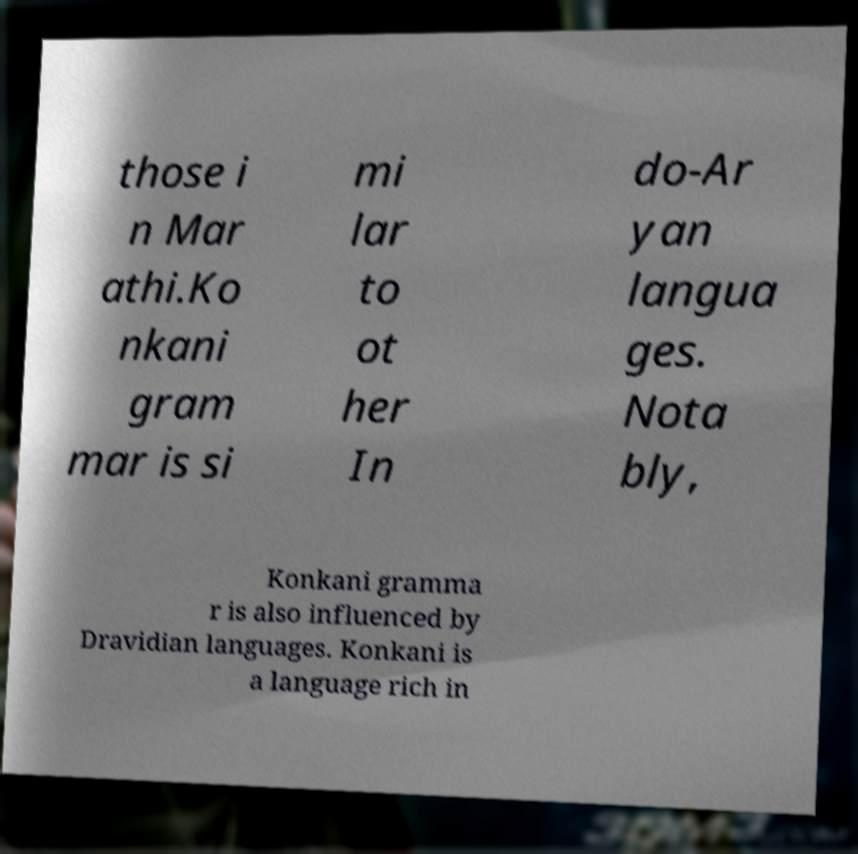For documentation purposes, I need the text within this image transcribed. Could you provide that? those i n Mar athi.Ko nkani gram mar is si mi lar to ot her In do-Ar yan langua ges. Nota bly, Konkani gramma r is also influenced by Dravidian languages. Konkani is a language rich in 